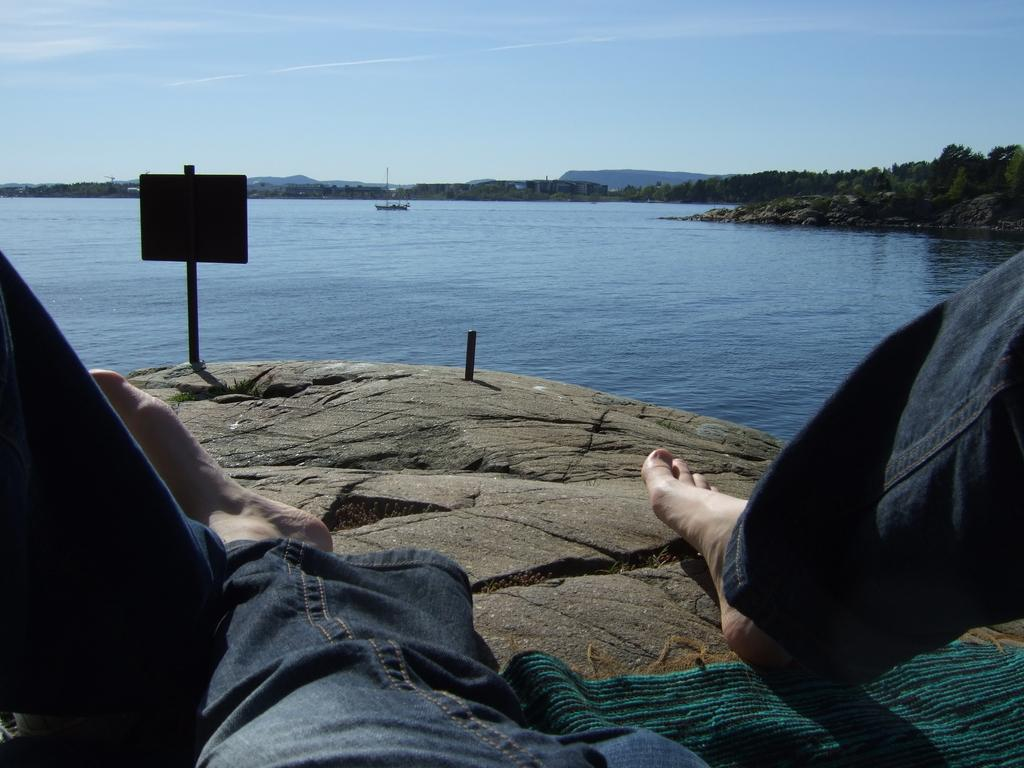Where is the person located in the image? The person is at the bottom side of the image on a rock. What is the purpose of the notice board in the image? The purpose of the notice board is not specified in the image, but it is likely used for displaying information or announcements. What is the boat doing in the image? The boat is on the water in the image, but its specific activity is not clear. What type of vegetation is visible in the image? Trees are visible in the image. What is visible in the sky in the image? The sky is visible in the image. What geographical feature can be seen in the background of the image? It appears that there are mountains in the background of the image. What type of scissors is the person using to cut the trees in the image? There are no scissors visible in the image, and the person is not cutting any trees. How many hands does the person have in the image? The number of hands the person has is not visible in the image, as only one side of the person is shown. What religious symbols are present in the image? There are no religious symbols visible in the image. 